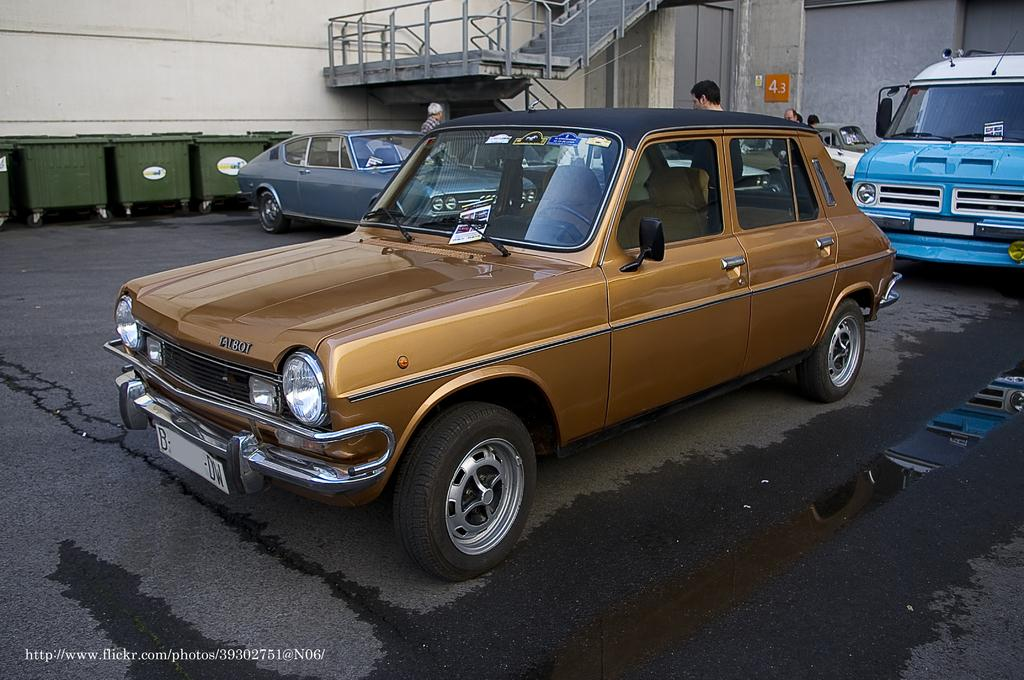What types of objects are present in the image? There are vehicles, people, stairs, and trolleys in the image. Can you describe the setting of the image? The image features a location with vehicles, people, stairs, and trolleys, which suggests it might be a transportation hub or station. What is on the wall of a building in the image? There is a poster on the wall of a building in the image. What type of ring can be seen on the writer's finger in the image? There is no writer or ring present in the image. How many cherries are on the trolley in the image? There is no mention of cherries in the image; only vehicles, people, stairs, trolleys, and a poster are present. 